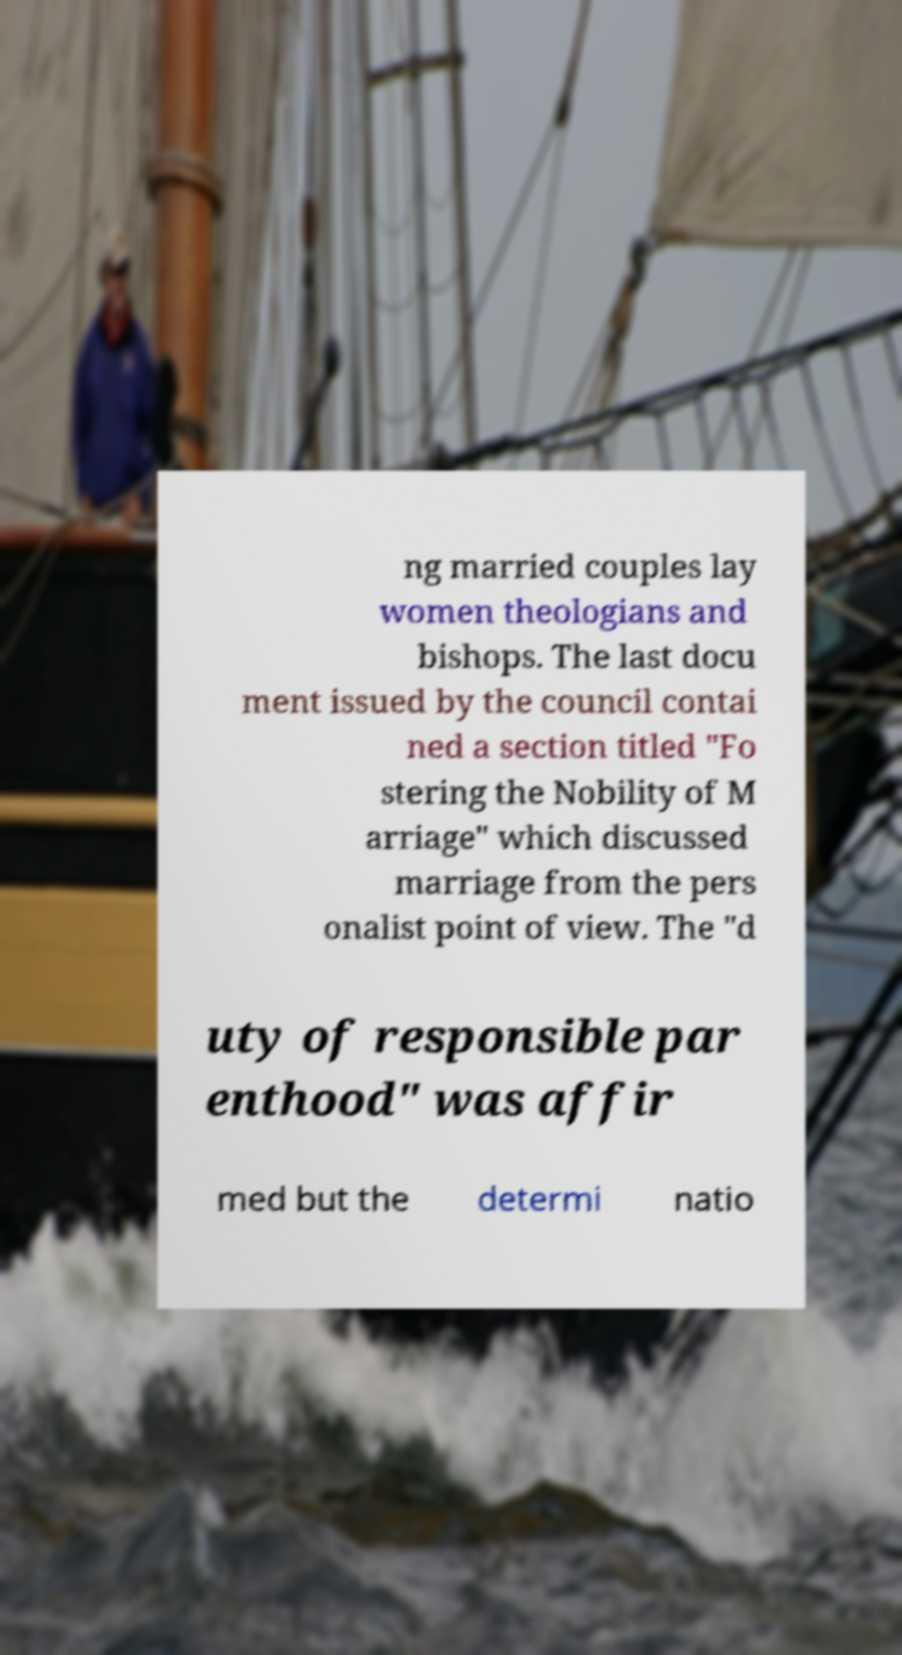Can you read and provide the text displayed in the image?This photo seems to have some interesting text. Can you extract and type it out for me? ng married couples lay women theologians and bishops. The last docu ment issued by the council contai ned a section titled "Fo stering the Nobility of M arriage" which discussed marriage from the pers onalist point of view. The "d uty of responsible par enthood" was affir med but the determi natio 